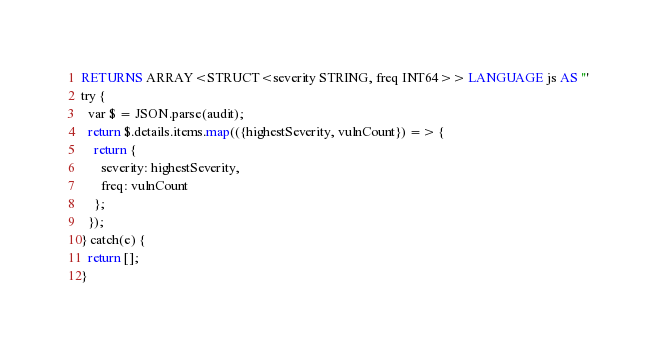<code> <loc_0><loc_0><loc_500><loc_500><_SQL_>RETURNS ARRAY<STRUCT<severity STRING, freq INT64>> LANGUAGE js AS '''
try {
  var $ = JSON.parse(audit);
  return $.details.items.map(({highestSeverity, vulnCount}) => {
    return {
      severity: highestSeverity,
      freq: vulnCount
    };
  });
} catch(e) {
  return [];
}</code> 